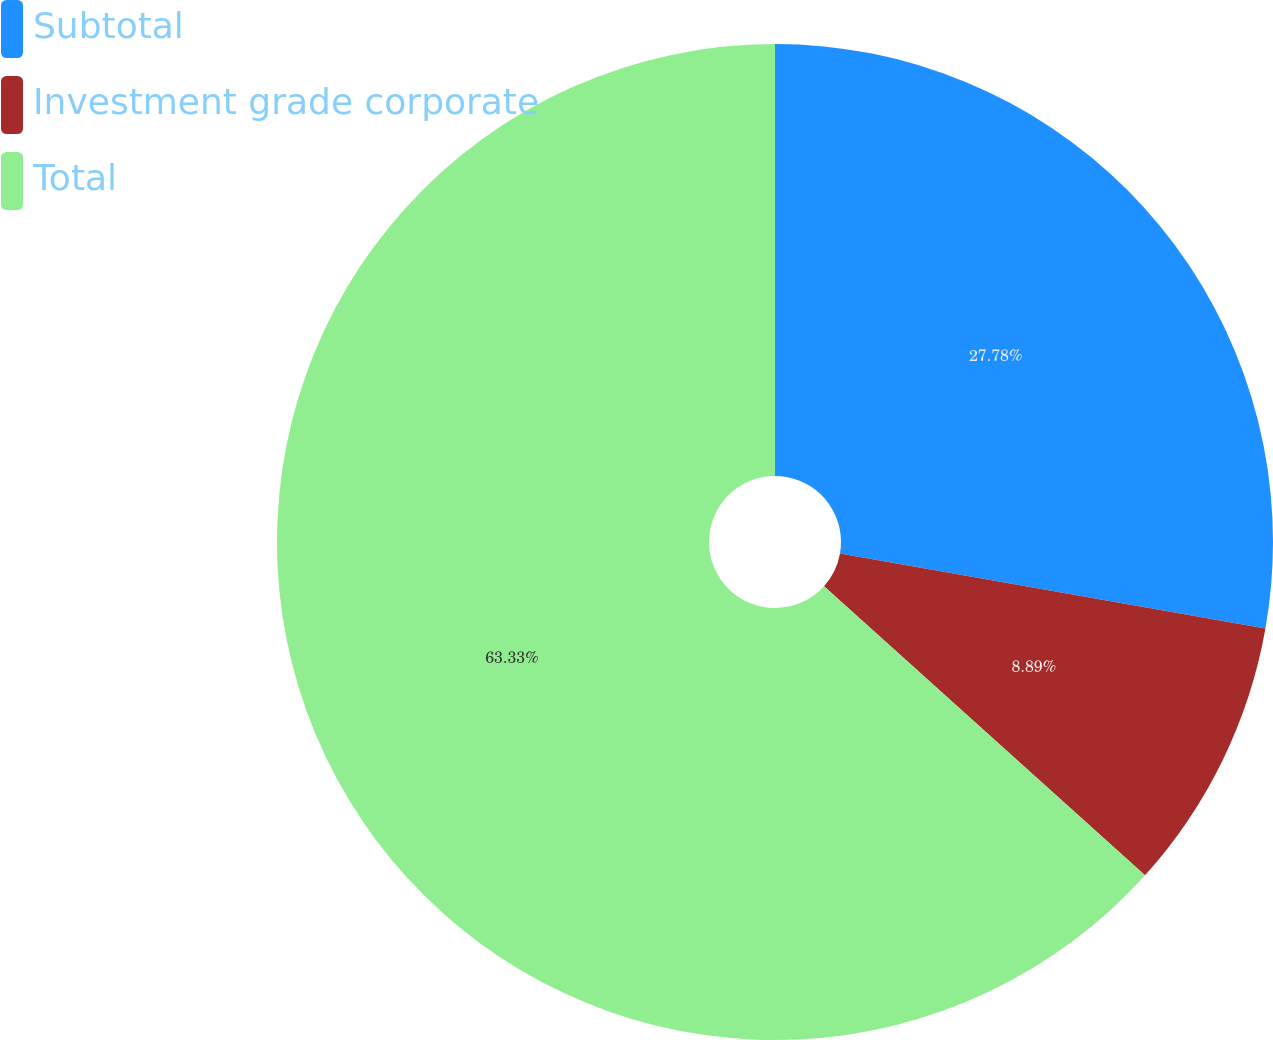<chart> <loc_0><loc_0><loc_500><loc_500><pie_chart><fcel>Subtotal<fcel>Investment grade corporate<fcel>Total<nl><fcel>27.78%<fcel>8.89%<fcel>63.33%<nl></chart> 